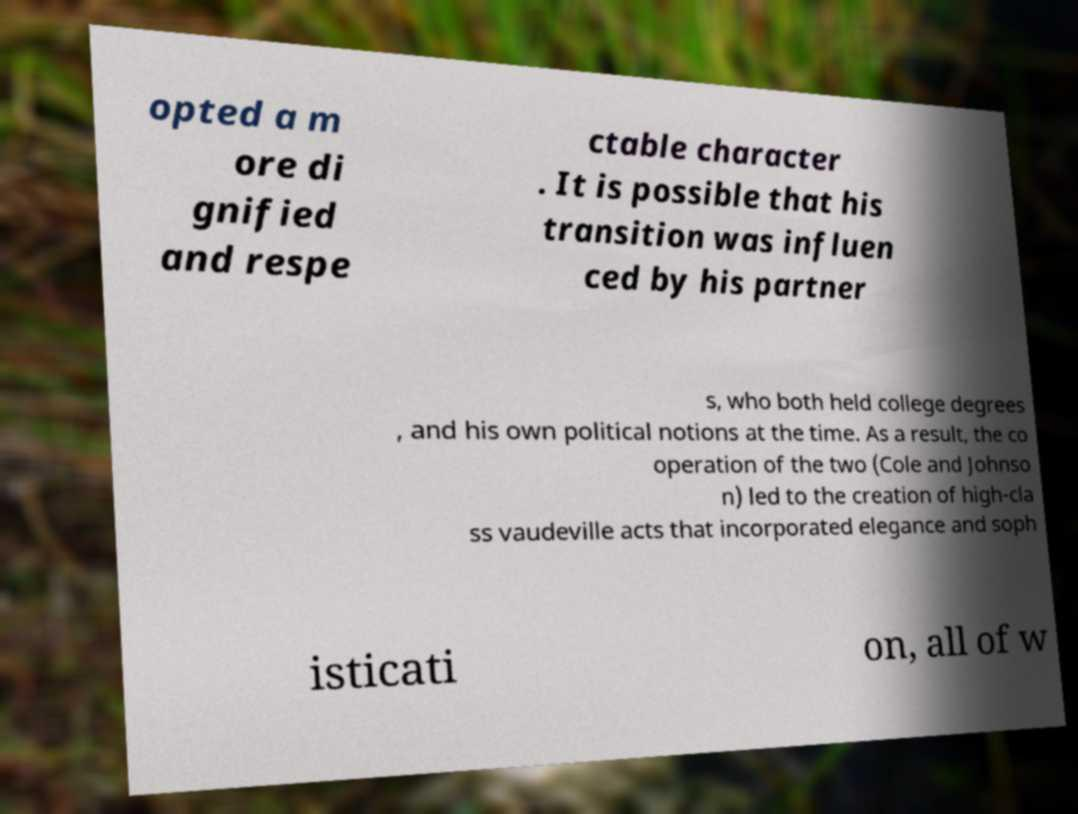Please identify and transcribe the text found in this image. opted a m ore di gnified and respe ctable character . It is possible that his transition was influen ced by his partner s, who both held college degrees , and his own political notions at the time. As a result, the co operation of the two (Cole and Johnso n) led to the creation of high-cla ss vaudeville acts that incorporated elegance and soph isticati on, all of w 